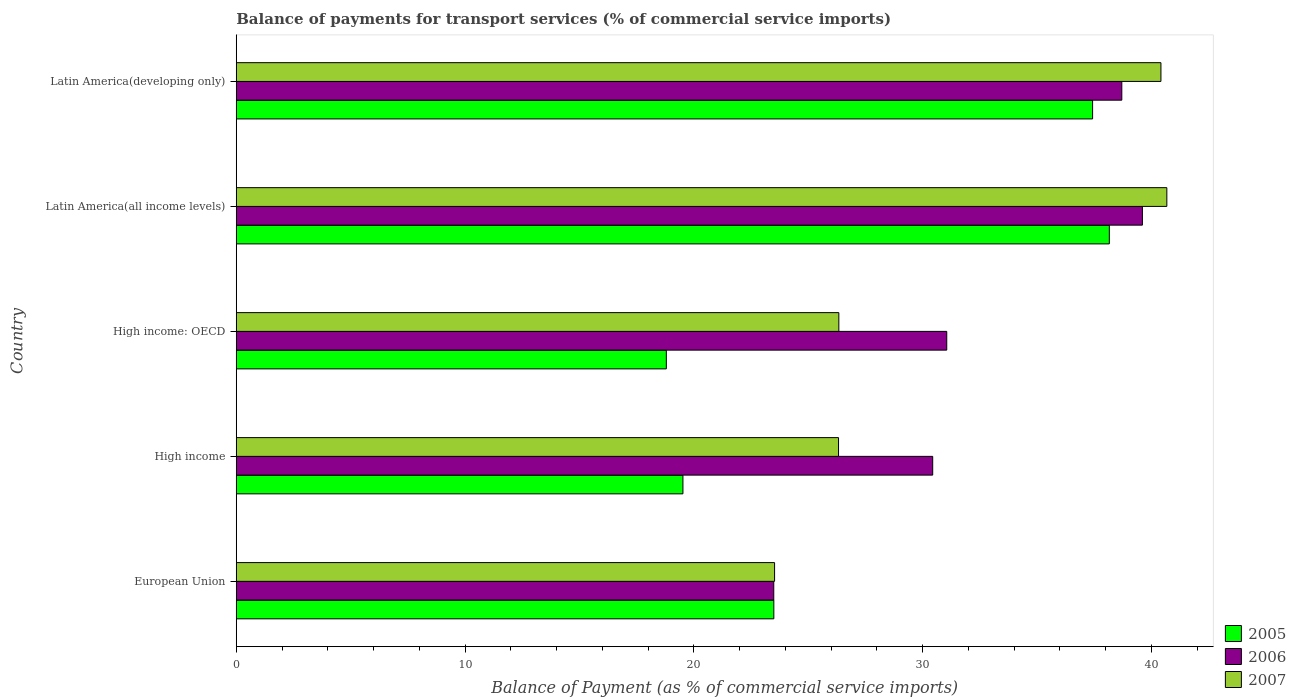How many different coloured bars are there?
Ensure brevity in your answer.  3. Are the number of bars on each tick of the Y-axis equal?
Give a very brief answer. Yes. How many bars are there on the 3rd tick from the bottom?
Give a very brief answer. 3. What is the label of the 4th group of bars from the top?
Ensure brevity in your answer.  High income. What is the balance of payments for transport services in 2005 in European Union?
Give a very brief answer. 23.5. Across all countries, what is the maximum balance of payments for transport services in 2007?
Make the answer very short. 40.68. Across all countries, what is the minimum balance of payments for transport services in 2005?
Offer a terse response. 18.8. In which country was the balance of payments for transport services in 2006 maximum?
Ensure brevity in your answer.  Latin America(all income levels). What is the total balance of payments for transport services in 2006 in the graph?
Make the answer very short. 163.32. What is the difference between the balance of payments for transport services in 2007 in European Union and that in High income: OECD?
Your answer should be very brief. -2.81. What is the difference between the balance of payments for transport services in 2007 in Latin America(all income levels) and the balance of payments for transport services in 2006 in Latin America(developing only)?
Ensure brevity in your answer.  1.97. What is the average balance of payments for transport services in 2006 per country?
Keep it short and to the point. 32.66. What is the difference between the balance of payments for transport services in 2005 and balance of payments for transport services in 2007 in Latin America(developing only)?
Keep it short and to the point. -2.99. In how many countries, is the balance of payments for transport services in 2006 greater than 36 %?
Your answer should be compact. 2. What is the ratio of the balance of payments for transport services in 2007 in High income to that in Latin America(all income levels)?
Your answer should be compact. 0.65. What is the difference between the highest and the second highest balance of payments for transport services in 2006?
Ensure brevity in your answer.  0.9. What is the difference between the highest and the lowest balance of payments for transport services in 2005?
Ensure brevity in your answer.  19.36. What does the 1st bar from the top in European Union represents?
Ensure brevity in your answer.  2007. What does the 3rd bar from the bottom in High income represents?
Your answer should be compact. 2007. Are all the bars in the graph horizontal?
Make the answer very short. Yes. Are the values on the major ticks of X-axis written in scientific E-notation?
Make the answer very short. No. Does the graph contain grids?
Provide a short and direct response. No. How are the legend labels stacked?
Keep it short and to the point. Vertical. What is the title of the graph?
Provide a succinct answer. Balance of payments for transport services (% of commercial service imports). Does "2001" appear as one of the legend labels in the graph?
Give a very brief answer. No. What is the label or title of the X-axis?
Your answer should be very brief. Balance of Payment (as % of commercial service imports). What is the Balance of Payment (as % of commercial service imports) of 2005 in European Union?
Offer a terse response. 23.5. What is the Balance of Payment (as % of commercial service imports) of 2006 in European Union?
Provide a succinct answer. 23.5. What is the Balance of Payment (as % of commercial service imports) in 2007 in European Union?
Offer a terse response. 23.53. What is the Balance of Payment (as % of commercial service imports) in 2005 in High income?
Your answer should be compact. 19.53. What is the Balance of Payment (as % of commercial service imports) in 2006 in High income?
Give a very brief answer. 30.44. What is the Balance of Payment (as % of commercial service imports) in 2007 in High income?
Provide a succinct answer. 26.33. What is the Balance of Payment (as % of commercial service imports) of 2005 in High income: OECD?
Your response must be concise. 18.8. What is the Balance of Payment (as % of commercial service imports) in 2006 in High income: OECD?
Make the answer very short. 31.06. What is the Balance of Payment (as % of commercial service imports) in 2007 in High income: OECD?
Offer a very short reply. 26.34. What is the Balance of Payment (as % of commercial service imports) in 2005 in Latin America(all income levels)?
Provide a short and direct response. 38.16. What is the Balance of Payment (as % of commercial service imports) in 2006 in Latin America(all income levels)?
Keep it short and to the point. 39.61. What is the Balance of Payment (as % of commercial service imports) of 2007 in Latin America(all income levels)?
Your answer should be compact. 40.68. What is the Balance of Payment (as % of commercial service imports) in 2005 in Latin America(developing only)?
Provide a succinct answer. 37.43. What is the Balance of Payment (as % of commercial service imports) in 2006 in Latin America(developing only)?
Give a very brief answer. 38.71. What is the Balance of Payment (as % of commercial service imports) in 2007 in Latin America(developing only)?
Your answer should be compact. 40.42. Across all countries, what is the maximum Balance of Payment (as % of commercial service imports) of 2005?
Keep it short and to the point. 38.16. Across all countries, what is the maximum Balance of Payment (as % of commercial service imports) of 2006?
Give a very brief answer. 39.61. Across all countries, what is the maximum Balance of Payment (as % of commercial service imports) of 2007?
Give a very brief answer. 40.68. Across all countries, what is the minimum Balance of Payment (as % of commercial service imports) of 2005?
Your response must be concise. 18.8. Across all countries, what is the minimum Balance of Payment (as % of commercial service imports) of 2006?
Make the answer very short. 23.5. Across all countries, what is the minimum Balance of Payment (as % of commercial service imports) in 2007?
Ensure brevity in your answer.  23.53. What is the total Balance of Payment (as % of commercial service imports) of 2005 in the graph?
Provide a succinct answer. 137.42. What is the total Balance of Payment (as % of commercial service imports) in 2006 in the graph?
Provide a succinct answer. 163.32. What is the total Balance of Payment (as % of commercial service imports) in 2007 in the graph?
Provide a succinct answer. 157.3. What is the difference between the Balance of Payment (as % of commercial service imports) in 2005 in European Union and that in High income?
Your answer should be compact. 3.97. What is the difference between the Balance of Payment (as % of commercial service imports) in 2006 in European Union and that in High income?
Your answer should be very brief. -6.95. What is the difference between the Balance of Payment (as % of commercial service imports) in 2007 in European Union and that in High income?
Provide a short and direct response. -2.8. What is the difference between the Balance of Payment (as % of commercial service imports) in 2005 in European Union and that in High income: OECD?
Provide a succinct answer. 4.7. What is the difference between the Balance of Payment (as % of commercial service imports) of 2006 in European Union and that in High income: OECD?
Provide a succinct answer. -7.56. What is the difference between the Balance of Payment (as % of commercial service imports) of 2007 in European Union and that in High income: OECD?
Make the answer very short. -2.81. What is the difference between the Balance of Payment (as % of commercial service imports) in 2005 in European Union and that in Latin America(all income levels)?
Give a very brief answer. -14.66. What is the difference between the Balance of Payment (as % of commercial service imports) of 2006 in European Union and that in Latin America(all income levels)?
Make the answer very short. -16.11. What is the difference between the Balance of Payment (as % of commercial service imports) in 2007 in European Union and that in Latin America(all income levels)?
Offer a terse response. -17.15. What is the difference between the Balance of Payment (as % of commercial service imports) in 2005 in European Union and that in Latin America(developing only)?
Your answer should be compact. -13.93. What is the difference between the Balance of Payment (as % of commercial service imports) of 2006 in European Union and that in Latin America(developing only)?
Ensure brevity in your answer.  -15.21. What is the difference between the Balance of Payment (as % of commercial service imports) in 2007 in European Union and that in Latin America(developing only)?
Offer a very short reply. -16.89. What is the difference between the Balance of Payment (as % of commercial service imports) in 2005 in High income and that in High income: OECD?
Your answer should be compact. 0.73. What is the difference between the Balance of Payment (as % of commercial service imports) of 2006 in High income and that in High income: OECD?
Your answer should be compact. -0.61. What is the difference between the Balance of Payment (as % of commercial service imports) of 2007 in High income and that in High income: OECD?
Offer a very short reply. -0.01. What is the difference between the Balance of Payment (as % of commercial service imports) in 2005 in High income and that in Latin America(all income levels)?
Keep it short and to the point. -18.64. What is the difference between the Balance of Payment (as % of commercial service imports) in 2006 in High income and that in Latin America(all income levels)?
Make the answer very short. -9.17. What is the difference between the Balance of Payment (as % of commercial service imports) of 2007 in High income and that in Latin America(all income levels)?
Provide a succinct answer. -14.35. What is the difference between the Balance of Payment (as % of commercial service imports) of 2005 in High income and that in Latin America(developing only)?
Provide a short and direct response. -17.91. What is the difference between the Balance of Payment (as % of commercial service imports) in 2006 in High income and that in Latin America(developing only)?
Give a very brief answer. -8.27. What is the difference between the Balance of Payment (as % of commercial service imports) of 2007 in High income and that in Latin America(developing only)?
Make the answer very short. -14.09. What is the difference between the Balance of Payment (as % of commercial service imports) of 2005 in High income: OECD and that in Latin America(all income levels)?
Offer a very short reply. -19.36. What is the difference between the Balance of Payment (as % of commercial service imports) of 2006 in High income: OECD and that in Latin America(all income levels)?
Make the answer very short. -8.55. What is the difference between the Balance of Payment (as % of commercial service imports) of 2007 in High income: OECD and that in Latin America(all income levels)?
Give a very brief answer. -14.34. What is the difference between the Balance of Payment (as % of commercial service imports) of 2005 in High income: OECD and that in Latin America(developing only)?
Provide a short and direct response. -18.63. What is the difference between the Balance of Payment (as % of commercial service imports) in 2006 in High income: OECD and that in Latin America(developing only)?
Your answer should be very brief. -7.65. What is the difference between the Balance of Payment (as % of commercial service imports) in 2007 in High income: OECD and that in Latin America(developing only)?
Provide a short and direct response. -14.08. What is the difference between the Balance of Payment (as % of commercial service imports) of 2005 in Latin America(all income levels) and that in Latin America(developing only)?
Provide a short and direct response. 0.73. What is the difference between the Balance of Payment (as % of commercial service imports) in 2006 in Latin America(all income levels) and that in Latin America(developing only)?
Offer a very short reply. 0.9. What is the difference between the Balance of Payment (as % of commercial service imports) of 2007 in Latin America(all income levels) and that in Latin America(developing only)?
Your answer should be very brief. 0.26. What is the difference between the Balance of Payment (as % of commercial service imports) in 2005 in European Union and the Balance of Payment (as % of commercial service imports) in 2006 in High income?
Ensure brevity in your answer.  -6.94. What is the difference between the Balance of Payment (as % of commercial service imports) in 2005 in European Union and the Balance of Payment (as % of commercial service imports) in 2007 in High income?
Ensure brevity in your answer.  -2.83. What is the difference between the Balance of Payment (as % of commercial service imports) in 2006 in European Union and the Balance of Payment (as % of commercial service imports) in 2007 in High income?
Offer a very short reply. -2.83. What is the difference between the Balance of Payment (as % of commercial service imports) in 2005 in European Union and the Balance of Payment (as % of commercial service imports) in 2006 in High income: OECD?
Provide a succinct answer. -7.56. What is the difference between the Balance of Payment (as % of commercial service imports) in 2005 in European Union and the Balance of Payment (as % of commercial service imports) in 2007 in High income: OECD?
Provide a short and direct response. -2.84. What is the difference between the Balance of Payment (as % of commercial service imports) of 2006 in European Union and the Balance of Payment (as % of commercial service imports) of 2007 in High income: OECD?
Give a very brief answer. -2.85. What is the difference between the Balance of Payment (as % of commercial service imports) in 2005 in European Union and the Balance of Payment (as % of commercial service imports) in 2006 in Latin America(all income levels)?
Offer a terse response. -16.11. What is the difference between the Balance of Payment (as % of commercial service imports) of 2005 in European Union and the Balance of Payment (as % of commercial service imports) of 2007 in Latin America(all income levels)?
Ensure brevity in your answer.  -17.18. What is the difference between the Balance of Payment (as % of commercial service imports) in 2006 in European Union and the Balance of Payment (as % of commercial service imports) in 2007 in Latin America(all income levels)?
Provide a succinct answer. -17.18. What is the difference between the Balance of Payment (as % of commercial service imports) of 2005 in European Union and the Balance of Payment (as % of commercial service imports) of 2006 in Latin America(developing only)?
Keep it short and to the point. -15.21. What is the difference between the Balance of Payment (as % of commercial service imports) of 2005 in European Union and the Balance of Payment (as % of commercial service imports) of 2007 in Latin America(developing only)?
Make the answer very short. -16.92. What is the difference between the Balance of Payment (as % of commercial service imports) in 2006 in European Union and the Balance of Payment (as % of commercial service imports) in 2007 in Latin America(developing only)?
Offer a terse response. -16.92. What is the difference between the Balance of Payment (as % of commercial service imports) of 2005 in High income and the Balance of Payment (as % of commercial service imports) of 2006 in High income: OECD?
Provide a succinct answer. -11.53. What is the difference between the Balance of Payment (as % of commercial service imports) in 2005 in High income and the Balance of Payment (as % of commercial service imports) in 2007 in High income: OECD?
Keep it short and to the point. -6.81. What is the difference between the Balance of Payment (as % of commercial service imports) of 2006 in High income and the Balance of Payment (as % of commercial service imports) of 2007 in High income: OECD?
Make the answer very short. 4.1. What is the difference between the Balance of Payment (as % of commercial service imports) in 2005 in High income and the Balance of Payment (as % of commercial service imports) in 2006 in Latin America(all income levels)?
Keep it short and to the point. -20.08. What is the difference between the Balance of Payment (as % of commercial service imports) of 2005 in High income and the Balance of Payment (as % of commercial service imports) of 2007 in Latin America(all income levels)?
Offer a terse response. -21.15. What is the difference between the Balance of Payment (as % of commercial service imports) in 2006 in High income and the Balance of Payment (as % of commercial service imports) in 2007 in Latin America(all income levels)?
Ensure brevity in your answer.  -10.23. What is the difference between the Balance of Payment (as % of commercial service imports) in 2005 in High income and the Balance of Payment (as % of commercial service imports) in 2006 in Latin America(developing only)?
Your response must be concise. -19.18. What is the difference between the Balance of Payment (as % of commercial service imports) in 2005 in High income and the Balance of Payment (as % of commercial service imports) in 2007 in Latin America(developing only)?
Make the answer very short. -20.89. What is the difference between the Balance of Payment (as % of commercial service imports) of 2006 in High income and the Balance of Payment (as % of commercial service imports) of 2007 in Latin America(developing only)?
Offer a very short reply. -9.98. What is the difference between the Balance of Payment (as % of commercial service imports) in 2005 in High income: OECD and the Balance of Payment (as % of commercial service imports) in 2006 in Latin America(all income levels)?
Offer a terse response. -20.81. What is the difference between the Balance of Payment (as % of commercial service imports) of 2005 in High income: OECD and the Balance of Payment (as % of commercial service imports) of 2007 in Latin America(all income levels)?
Provide a short and direct response. -21.88. What is the difference between the Balance of Payment (as % of commercial service imports) in 2006 in High income: OECD and the Balance of Payment (as % of commercial service imports) in 2007 in Latin America(all income levels)?
Give a very brief answer. -9.62. What is the difference between the Balance of Payment (as % of commercial service imports) of 2005 in High income: OECD and the Balance of Payment (as % of commercial service imports) of 2006 in Latin America(developing only)?
Offer a very short reply. -19.91. What is the difference between the Balance of Payment (as % of commercial service imports) of 2005 in High income: OECD and the Balance of Payment (as % of commercial service imports) of 2007 in Latin America(developing only)?
Provide a short and direct response. -21.62. What is the difference between the Balance of Payment (as % of commercial service imports) of 2006 in High income: OECD and the Balance of Payment (as % of commercial service imports) of 2007 in Latin America(developing only)?
Give a very brief answer. -9.36. What is the difference between the Balance of Payment (as % of commercial service imports) in 2005 in Latin America(all income levels) and the Balance of Payment (as % of commercial service imports) in 2006 in Latin America(developing only)?
Provide a short and direct response. -0.55. What is the difference between the Balance of Payment (as % of commercial service imports) of 2005 in Latin America(all income levels) and the Balance of Payment (as % of commercial service imports) of 2007 in Latin America(developing only)?
Your answer should be very brief. -2.26. What is the difference between the Balance of Payment (as % of commercial service imports) in 2006 in Latin America(all income levels) and the Balance of Payment (as % of commercial service imports) in 2007 in Latin America(developing only)?
Ensure brevity in your answer.  -0.81. What is the average Balance of Payment (as % of commercial service imports) of 2005 per country?
Keep it short and to the point. 27.48. What is the average Balance of Payment (as % of commercial service imports) of 2006 per country?
Your answer should be compact. 32.66. What is the average Balance of Payment (as % of commercial service imports) of 2007 per country?
Provide a short and direct response. 31.46. What is the difference between the Balance of Payment (as % of commercial service imports) in 2005 and Balance of Payment (as % of commercial service imports) in 2006 in European Union?
Offer a terse response. 0. What is the difference between the Balance of Payment (as % of commercial service imports) of 2005 and Balance of Payment (as % of commercial service imports) of 2007 in European Union?
Offer a terse response. -0.03. What is the difference between the Balance of Payment (as % of commercial service imports) of 2006 and Balance of Payment (as % of commercial service imports) of 2007 in European Union?
Ensure brevity in your answer.  -0.04. What is the difference between the Balance of Payment (as % of commercial service imports) of 2005 and Balance of Payment (as % of commercial service imports) of 2006 in High income?
Your response must be concise. -10.92. What is the difference between the Balance of Payment (as % of commercial service imports) in 2005 and Balance of Payment (as % of commercial service imports) in 2007 in High income?
Keep it short and to the point. -6.8. What is the difference between the Balance of Payment (as % of commercial service imports) of 2006 and Balance of Payment (as % of commercial service imports) of 2007 in High income?
Keep it short and to the point. 4.12. What is the difference between the Balance of Payment (as % of commercial service imports) of 2005 and Balance of Payment (as % of commercial service imports) of 2006 in High income: OECD?
Offer a very short reply. -12.26. What is the difference between the Balance of Payment (as % of commercial service imports) in 2005 and Balance of Payment (as % of commercial service imports) in 2007 in High income: OECD?
Your answer should be compact. -7.54. What is the difference between the Balance of Payment (as % of commercial service imports) in 2006 and Balance of Payment (as % of commercial service imports) in 2007 in High income: OECD?
Your response must be concise. 4.72. What is the difference between the Balance of Payment (as % of commercial service imports) in 2005 and Balance of Payment (as % of commercial service imports) in 2006 in Latin America(all income levels)?
Your answer should be very brief. -1.45. What is the difference between the Balance of Payment (as % of commercial service imports) in 2005 and Balance of Payment (as % of commercial service imports) in 2007 in Latin America(all income levels)?
Offer a very short reply. -2.51. What is the difference between the Balance of Payment (as % of commercial service imports) of 2006 and Balance of Payment (as % of commercial service imports) of 2007 in Latin America(all income levels)?
Make the answer very short. -1.07. What is the difference between the Balance of Payment (as % of commercial service imports) of 2005 and Balance of Payment (as % of commercial service imports) of 2006 in Latin America(developing only)?
Make the answer very short. -1.28. What is the difference between the Balance of Payment (as % of commercial service imports) of 2005 and Balance of Payment (as % of commercial service imports) of 2007 in Latin America(developing only)?
Your response must be concise. -2.99. What is the difference between the Balance of Payment (as % of commercial service imports) in 2006 and Balance of Payment (as % of commercial service imports) in 2007 in Latin America(developing only)?
Give a very brief answer. -1.71. What is the ratio of the Balance of Payment (as % of commercial service imports) in 2005 in European Union to that in High income?
Your answer should be very brief. 1.2. What is the ratio of the Balance of Payment (as % of commercial service imports) in 2006 in European Union to that in High income?
Your answer should be very brief. 0.77. What is the ratio of the Balance of Payment (as % of commercial service imports) in 2007 in European Union to that in High income?
Your answer should be compact. 0.89. What is the ratio of the Balance of Payment (as % of commercial service imports) of 2005 in European Union to that in High income: OECD?
Offer a very short reply. 1.25. What is the ratio of the Balance of Payment (as % of commercial service imports) of 2006 in European Union to that in High income: OECD?
Keep it short and to the point. 0.76. What is the ratio of the Balance of Payment (as % of commercial service imports) of 2007 in European Union to that in High income: OECD?
Offer a terse response. 0.89. What is the ratio of the Balance of Payment (as % of commercial service imports) of 2005 in European Union to that in Latin America(all income levels)?
Give a very brief answer. 0.62. What is the ratio of the Balance of Payment (as % of commercial service imports) in 2006 in European Union to that in Latin America(all income levels)?
Keep it short and to the point. 0.59. What is the ratio of the Balance of Payment (as % of commercial service imports) in 2007 in European Union to that in Latin America(all income levels)?
Keep it short and to the point. 0.58. What is the ratio of the Balance of Payment (as % of commercial service imports) of 2005 in European Union to that in Latin America(developing only)?
Ensure brevity in your answer.  0.63. What is the ratio of the Balance of Payment (as % of commercial service imports) of 2006 in European Union to that in Latin America(developing only)?
Ensure brevity in your answer.  0.61. What is the ratio of the Balance of Payment (as % of commercial service imports) of 2007 in European Union to that in Latin America(developing only)?
Make the answer very short. 0.58. What is the ratio of the Balance of Payment (as % of commercial service imports) of 2005 in High income to that in High income: OECD?
Make the answer very short. 1.04. What is the ratio of the Balance of Payment (as % of commercial service imports) in 2006 in High income to that in High income: OECD?
Offer a terse response. 0.98. What is the ratio of the Balance of Payment (as % of commercial service imports) in 2005 in High income to that in Latin America(all income levels)?
Provide a succinct answer. 0.51. What is the ratio of the Balance of Payment (as % of commercial service imports) of 2006 in High income to that in Latin America(all income levels)?
Offer a very short reply. 0.77. What is the ratio of the Balance of Payment (as % of commercial service imports) of 2007 in High income to that in Latin America(all income levels)?
Offer a very short reply. 0.65. What is the ratio of the Balance of Payment (as % of commercial service imports) of 2005 in High income to that in Latin America(developing only)?
Ensure brevity in your answer.  0.52. What is the ratio of the Balance of Payment (as % of commercial service imports) in 2006 in High income to that in Latin America(developing only)?
Ensure brevity in your answer.  0.79. What is the ratio of the Balance of Payment (as % of commercial service imports) of 2007 in High income to that in Latin America(developing only)?
Ensure brevity in your answer.  0.65. What is the ratio of the Balance of Payment (as % of commercial service imports) of 2005 in High income: OECD to that in Latin America(all income levels)?
Make the answer very short. 0.49. What is the ratio of the Balance of Payment (as % of commercial service imports) of 2006 in High income: OECD to that in Latin America(all income levels)?
Provide a succinct answer. 0.78. What is the ratio of the Balance of Payment (as % of commercial service imports) in 2007 in High income: OECD to that in Latin America(all income levels)?
Keep it short and to the point. 0.65. What is the ratio of the Balance of Payment (as % of commercial service imports) in 2005 in High income: OECD to that in Latin America(developing only)?
Provide a short and direct response. 0.5. What is the ratio of the Balance of Payment (as % of commercial service imports) in 2006 in High income: OECD to that in Latin America(developing only)?
Your response must be concise. 0.8. What is the ratio of the Balance of Payment (as % of commercial service imports) in 2007 in High income: OECD to that in Latin America(developing only)?
Provide a succinct answer. 0.65. What is the ratio of the Balance of Payment (as % of commercial service imports) in 2005 in Latin America(all income levels) to that in Latin America(developing only)?
Provide a short and direct response. 1.02. What is the ratio of the Balance of Payment (as % of commercial service imports) in 2006 in Latin America(all income levels) to that in Latin America(developing only)?
Ensure brevity in your answer.  1.02. What is the ratio of the Balance of Payment (as % of commercial service imports) in 2007 in Latin America(all income levels) to that in Latin America(developing only)?
Your answer should be very brief. 1.01. What is the difference between the highest and the second highest Balance of Payment (as % of commercial service imports) in 2005?
Give a very brief answer. 0.73. What is the difference between the highest and the second highest Balance of Payment (as % of commercial service imports) in 2006?
Give a very brief answer. 0.9. What is the difference between the highest and the second highest Balance of Payment (as % of commercial service imports) in 2007?
Provide a short and direct response. 0.26. What is the difference between the highest and the lowest Balance of Payment (as % of commercial service imports) of 2005?
Keep it short and to the point. 19.36. What is the difference between the highest and the lowest Balance of Payment (as % of commercial service imports) of 2006?
Give a very brief answer. 16.11. What is the difference between the highest and the lowest Balance of Payment (as % of commercial service imports) of 2007?
Make the answer very short. 17.15. 